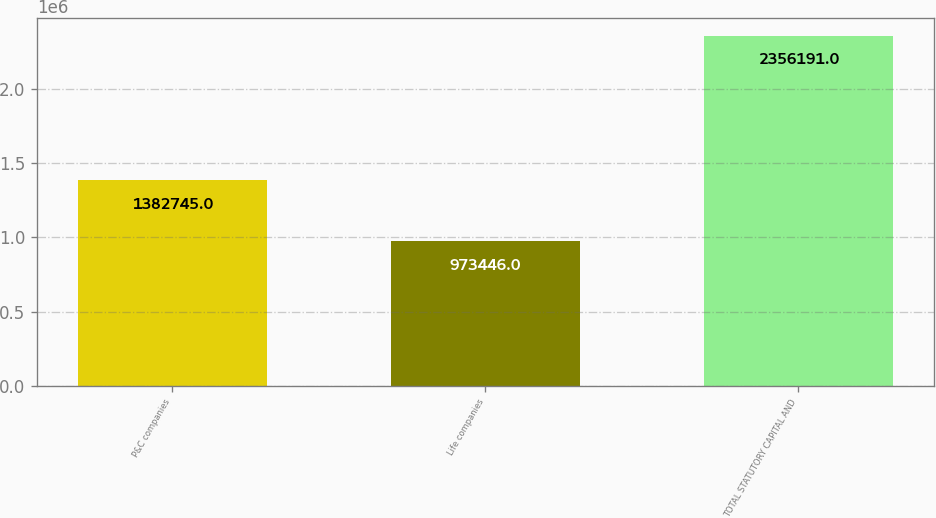<chart> <loc_0><loc_0><loc_500><loc_500><bar_chart><fcel>P&C companies<fcel>Life companies<fcel>TOTAL STATUTORY CAPITAL AND<nl><fcel>1.38274e+06<fcel>973446<fcel>2.35619e+06<nl></chart> 